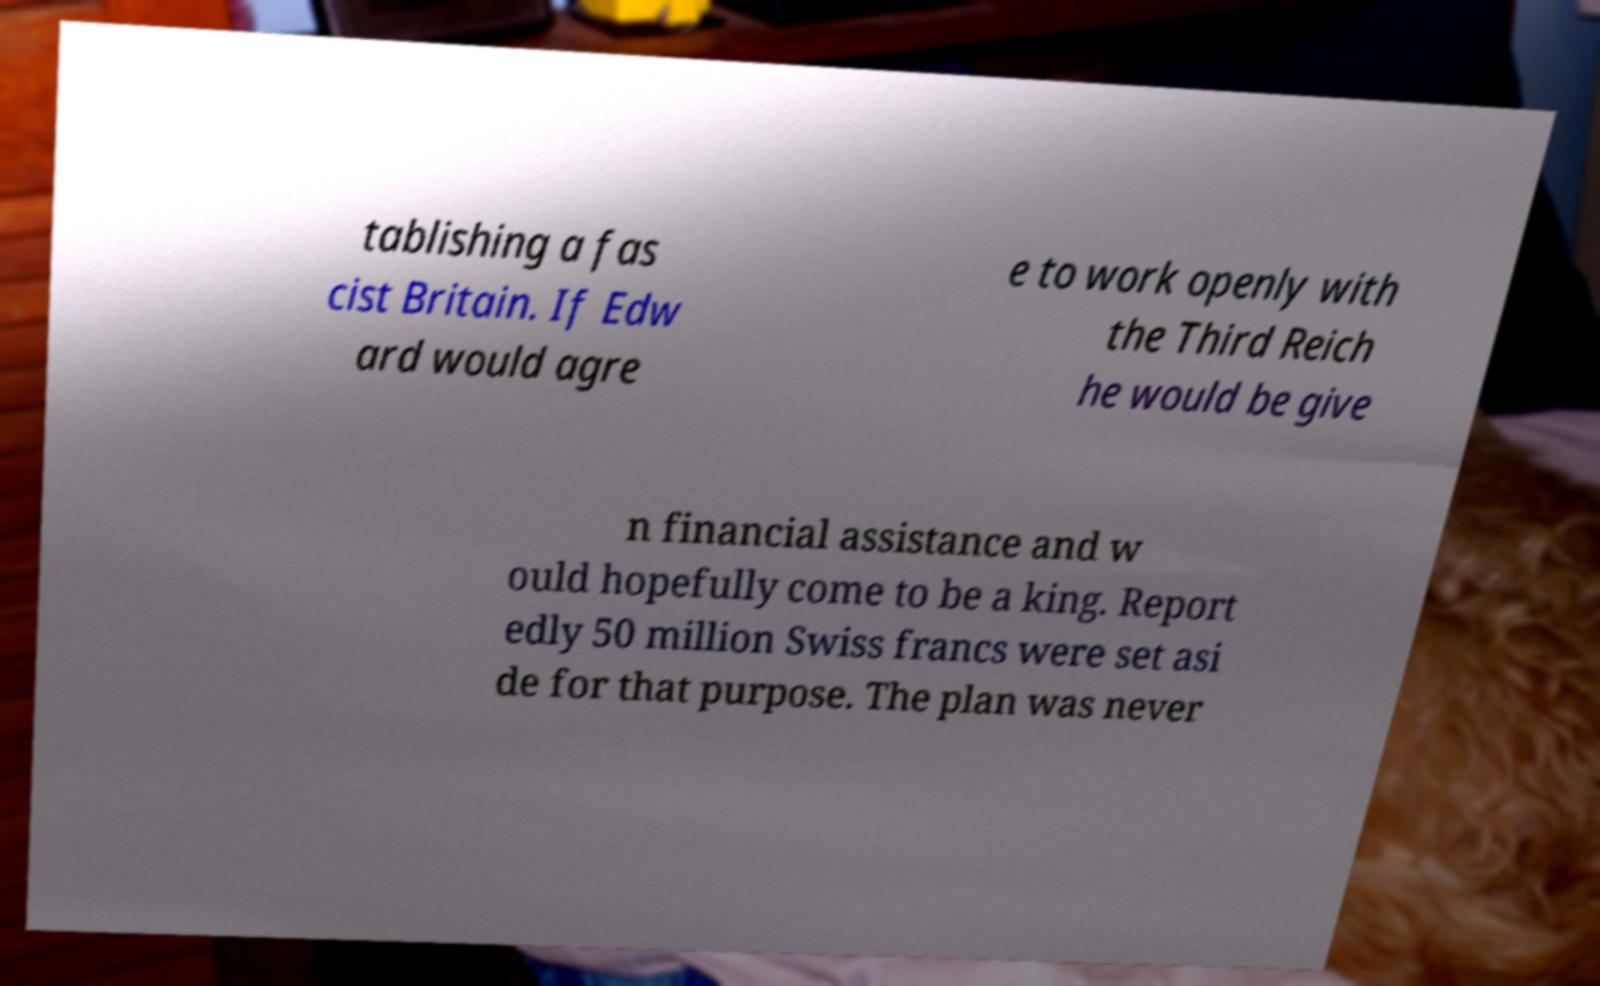Could you assist in decoding the text presented in this image and type it out clearly? tablishing a fas cist Britain. If Edw ard would agre e to work openly with the Third Reich he would be give n financial assistance and w ould hopefully come to be a king. Report edly 50 million Swiss francs were set asi de for that purpose. The plan was never 